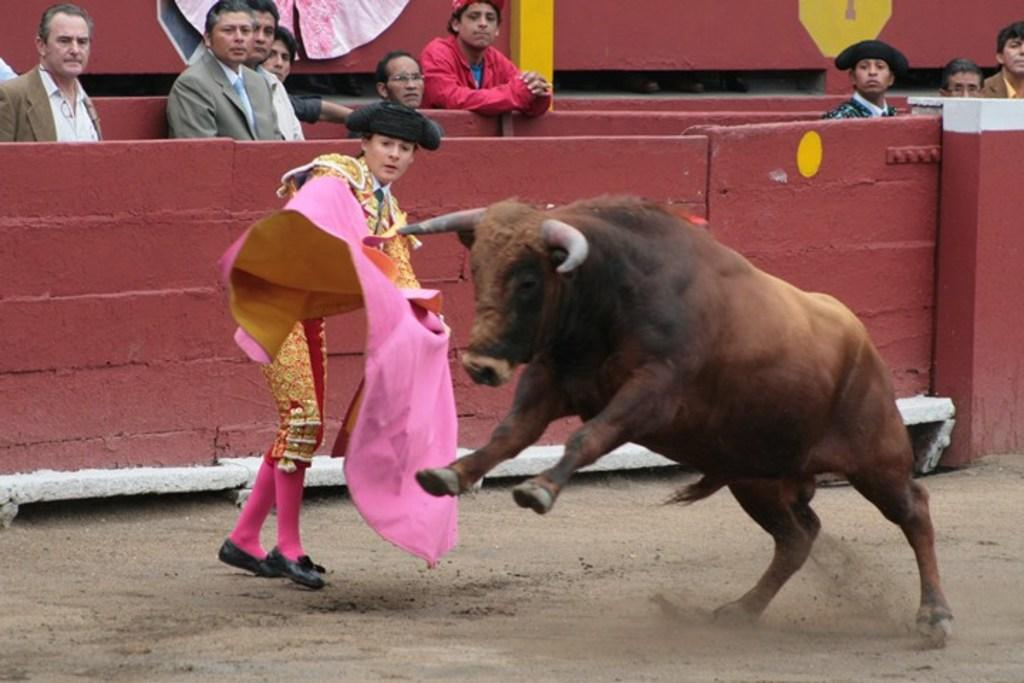What animal is present in the picture? There is a bull in the picture. Who else is present in the picture besides the bull? There is a woman standing in the picture, as well as people seated and standing. What is the woman wearing on her head? The woman is wearing a cap on her head. What are the people in the picture doing? Some people are seated, while others are standing and watching. What type of riddle is the bull trying to solve in the picture? There is no indication in the image that the bull is trying to solve a riddle; it is simply a bull standing in the scene. Can you tell me how many knives are visible in the picture? There is no knife present in the image; the focus is on the bull, the woman, and the people. 